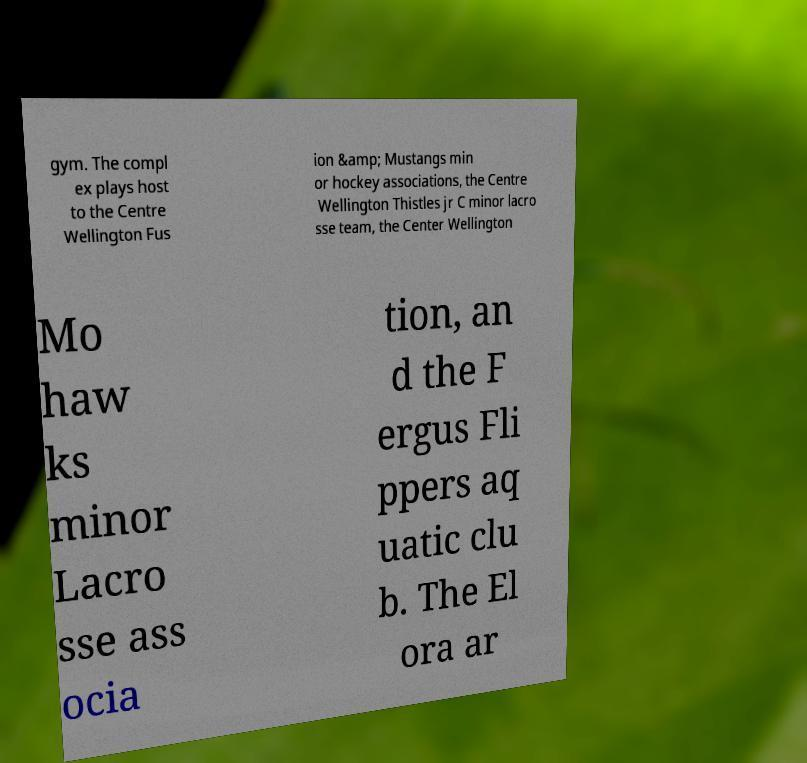I need the written content from this picture converted into text. Can you do that? gym. The compl ex plays host to the Centre Wellington Fus ion &amp; Mustangs min or hockey associations, the Centre Wellington Thistles jr C minor lacro sse team, the Center Wellington Mo haw ks minor Lacro sse ass ocia tion, an d the F ergus Fli ppers aq uatic clu b. The El ora ar 